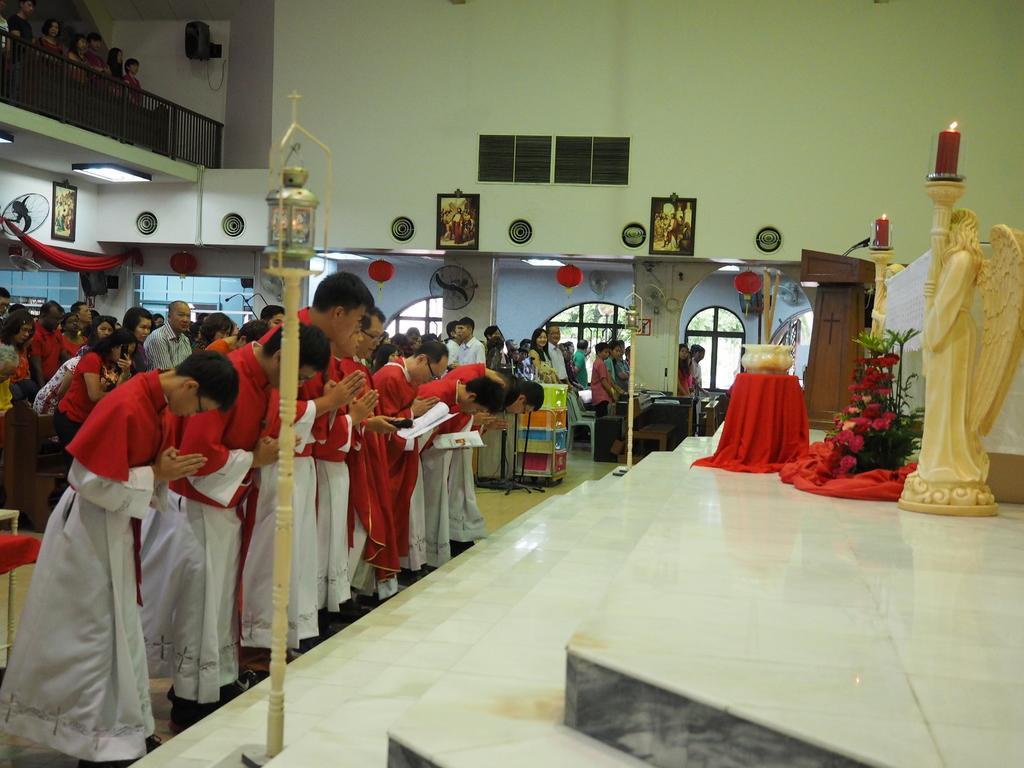Can you describe this image briefly? In this image we can see men and women are bowing their head in front of the statue and we can see poles, flowers, pot and stairs in the middle of the image. We can see glass windows and wall in the background of the image and frames are attached to the wall. We can see people are standing on the balcony which is in the top left of the image. 